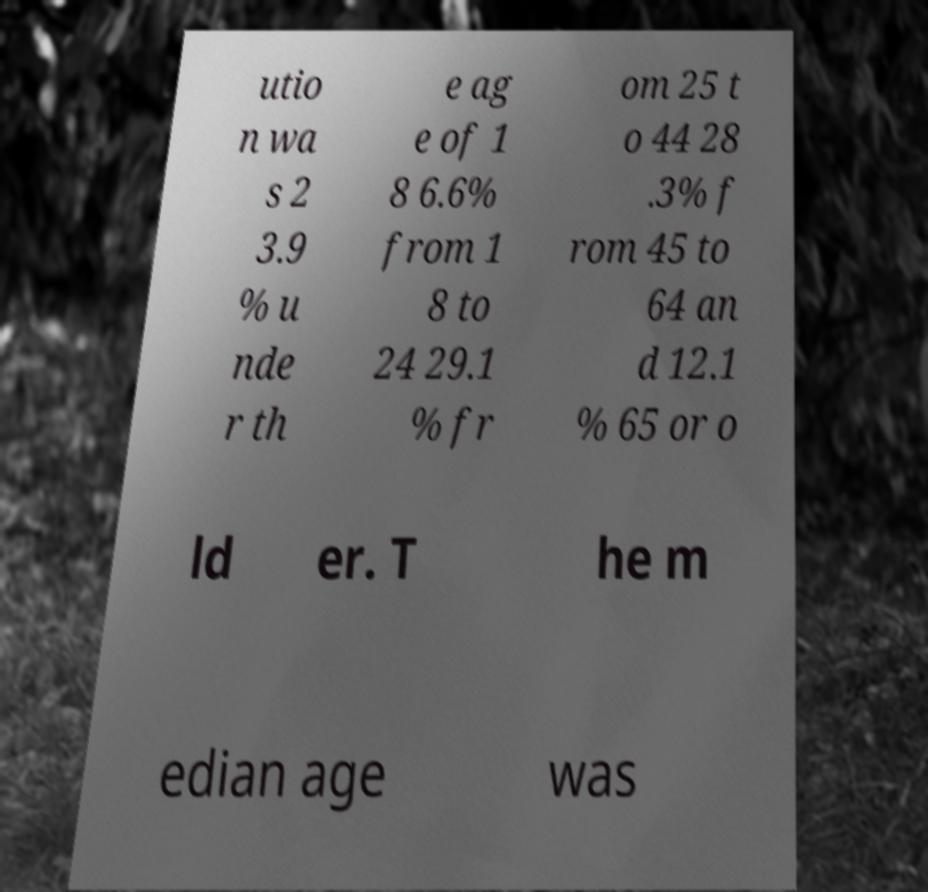Can you accurately transcribe the text from the provided image for me? utio n wa s 2 3.9 % u nde r th e ag e of 1 8 6.6% from 1 8 to 24 29.1 % fr om 25 t o 44 28 .3% f rom 45 to 64 an d 12.1 % 65 or o ld er. T he m edian age was 